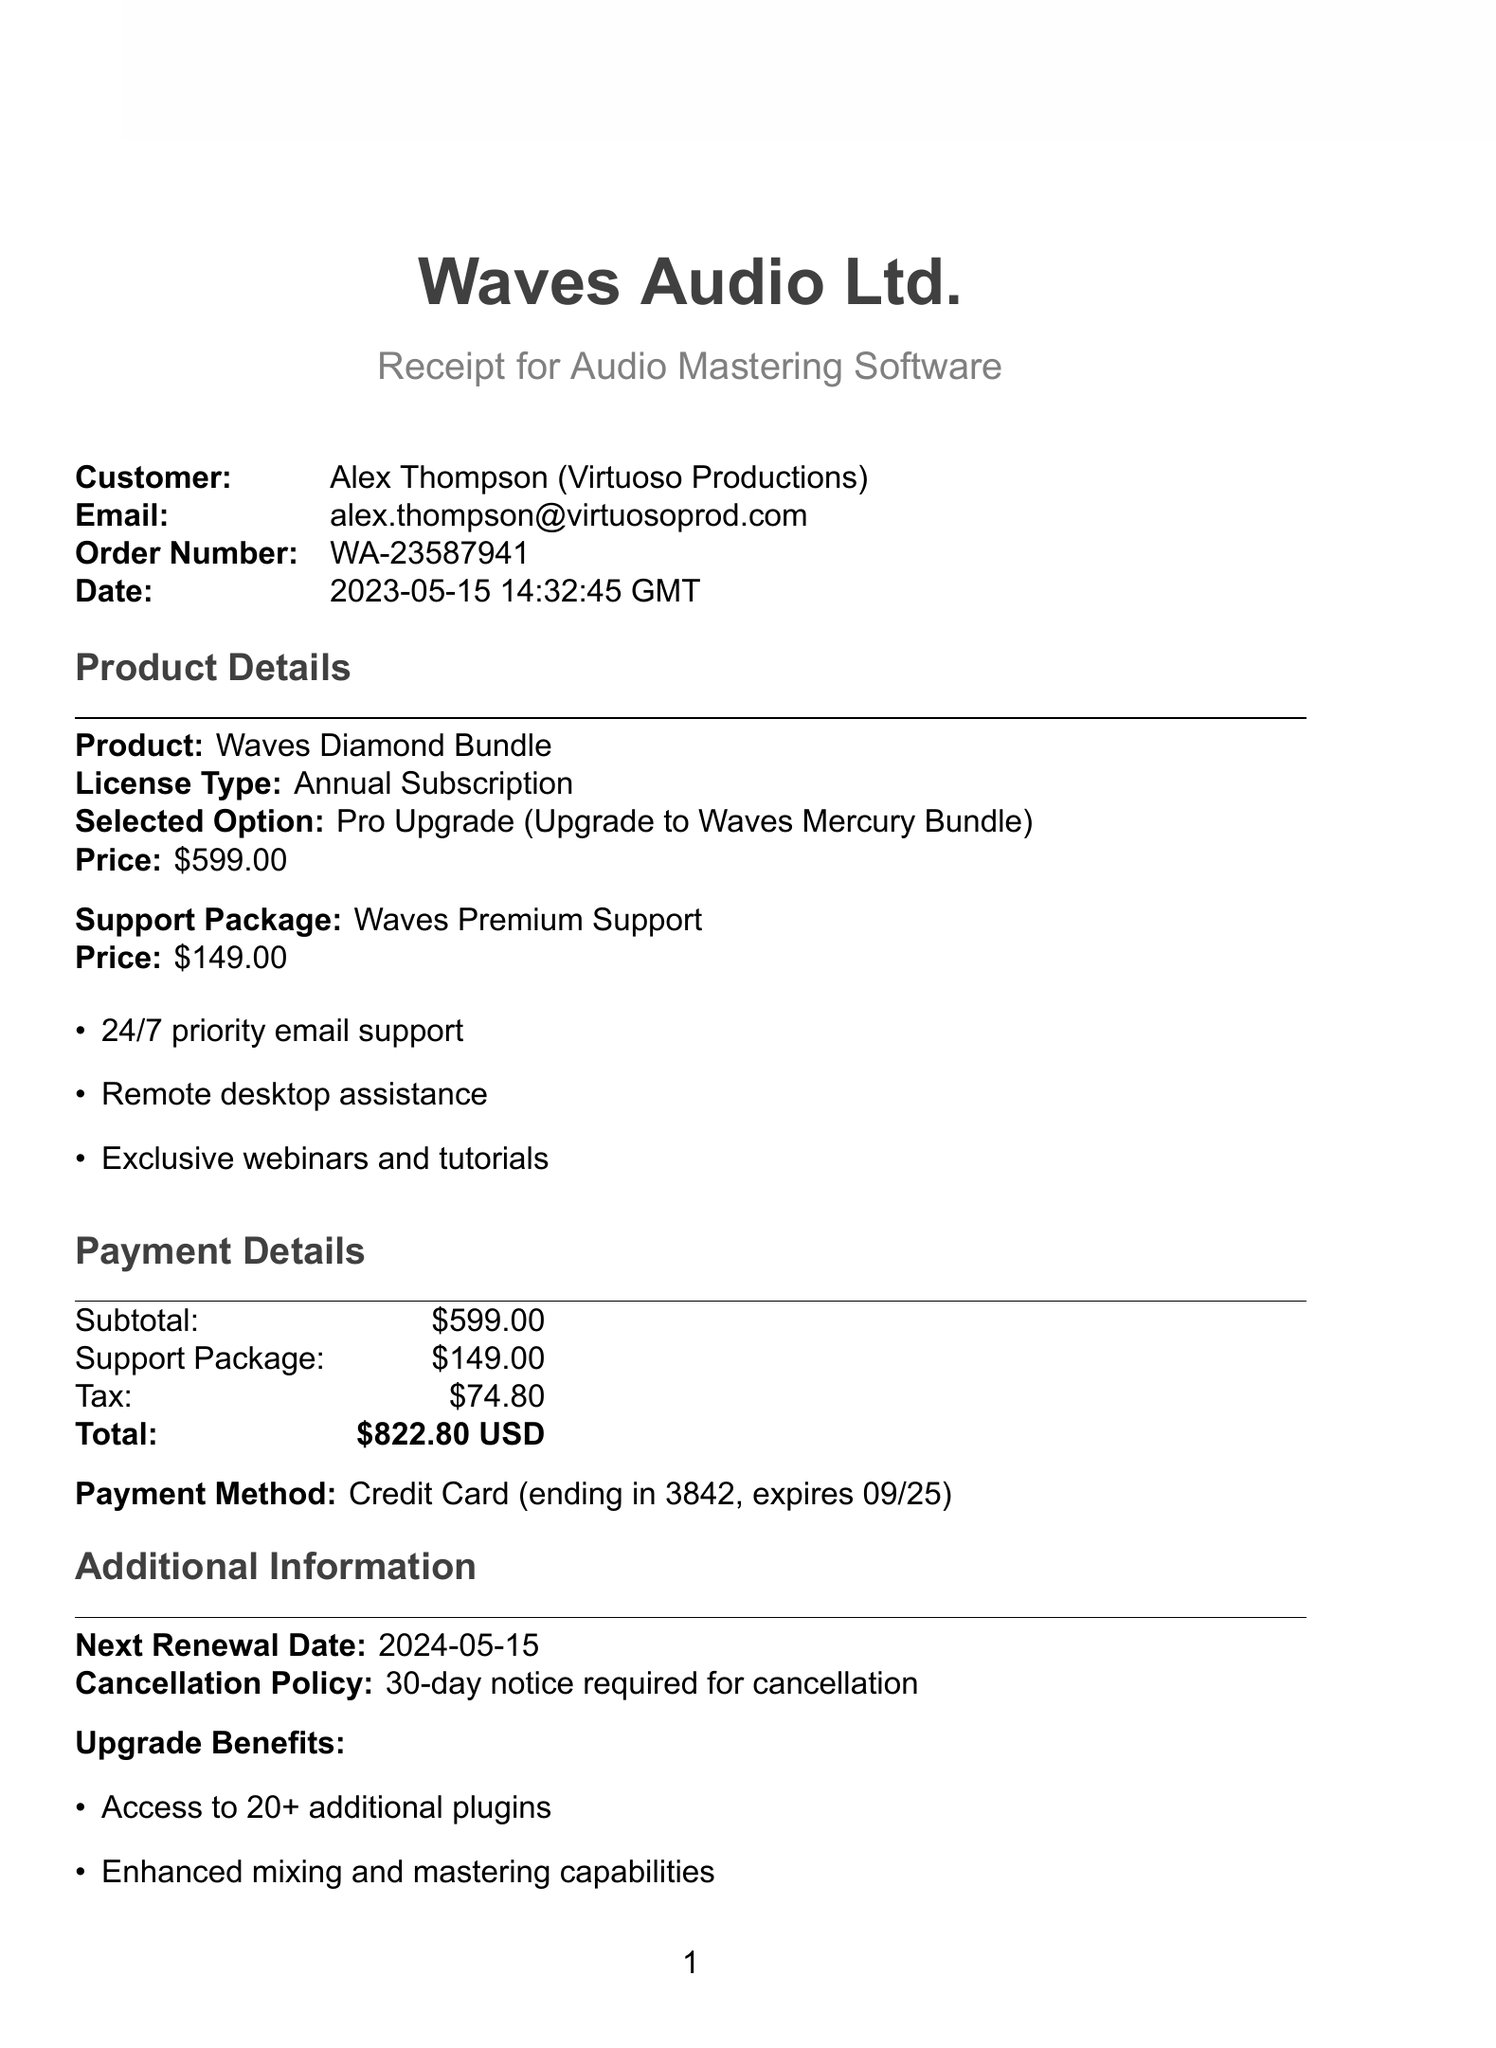What is the name of the customer? The document lists the customer's name as Alex Thompson.
Answer: Alex Thompson What is the total amount due? The total amount due is the sum of the subtotal, support package fee, and tax, which equals $599.00 + $149.00 + $74.80.
Answer: $822.80 What type of license has been renewed? The document states that the license type is an Annual Subscription.
Answer: Annual Subscription What is included in the support package? The document outlines the features of the Waves Premium Support package, which includes 24/7 priority email support, remote desktop assistance, and exclusive webinars and tutorials.
Answer: 24/7 priority email support, remote desktop assistance, exclusive webinars and tutorials What is the next renewal date? The next renewal date is specified in the additional information section of the document.
Answer: 2024-05-15 What is the order number? The order number is provided in the transaction details section of the receipt.
Answer: WA-23587941 What is the cancellation policy? The cancellation policy is described in the additional information section, which states a notice is required.
Answer: 30-day notice required for cancellation What is the price of the Pro Upgrade? The Pro Upgrade price is mentioned as part of the renewal options in the document.
Answer: $599.00 What payment method was used? The document specifies the payment method used to complete this transaction.
Answer: Credit Card 